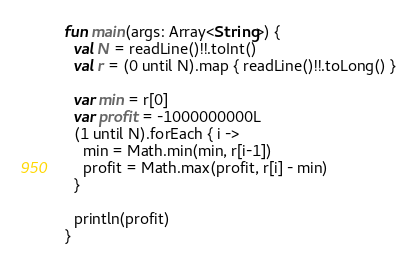<code> <loc_0><loc_0><loc_500><loc_500><_Kotlin_>fun main(args: Array<String>) {
  val N = readLine()!!.toInt()
  val r = (0 until N).map { readLine()!!.toLong() }

  var min = r[0]
  var profit = -1000000000L
  (1 until N).forEach { i ->
    min = Math.min(min, r[i-1]) 
    profit = Math.max(profit, r[i] - min)
  }  

  println(profit)
}
</code> 